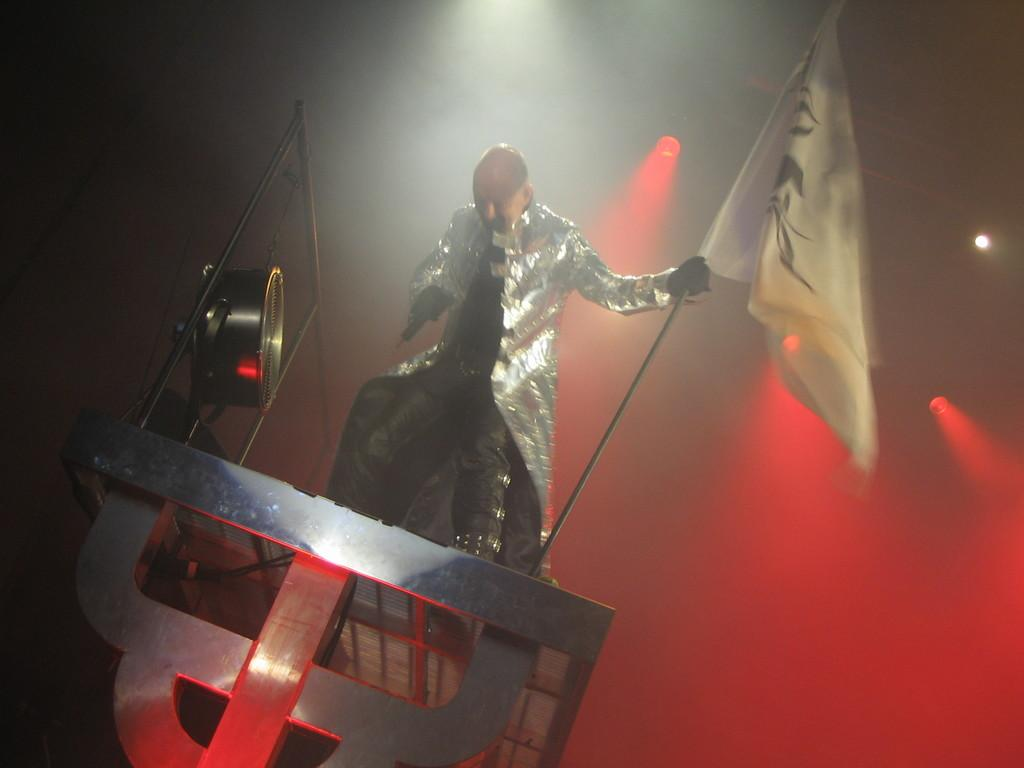What is the main subject of the image? There is a person in the image. What is the person doing in the image? The person is standing. What object is the person holding in the image? The person is holding a flag in his hand. What type of quartz can be seen in the person's pocket in the image? There is no quartz visible in the image, and the person's pocket is not mentioned in the provided facts. 